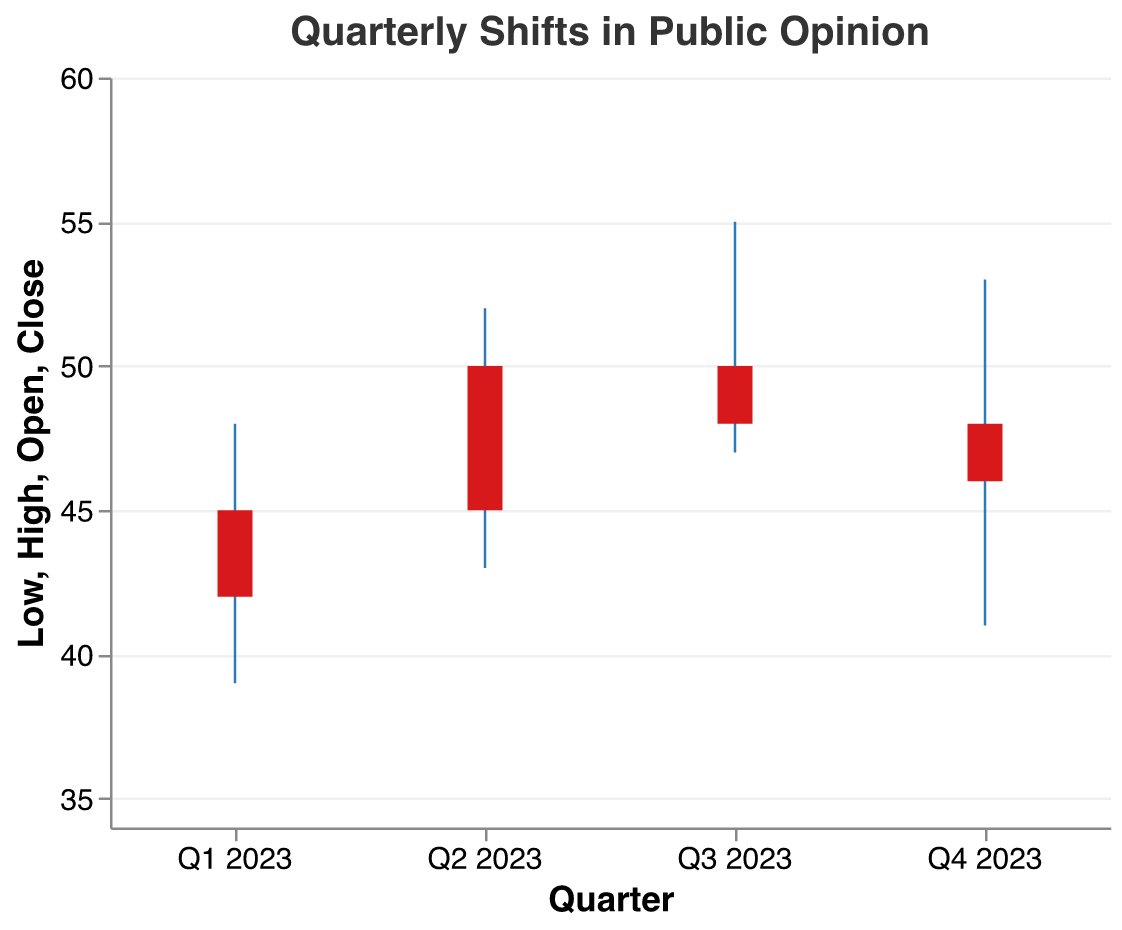What is the highest value of public opinion in Q3 2023? The highest value is represented by the "High" field for each quarter. For Q3 2023, the "High" value is 55
Answer: 55 What colors are used to represent the bar and the rule in the figure? The bar is colored red and the rule is colored blue
Answer: Red for bar, blue for rule What is the title of the figure? The title of the figure appears at the top and is: "Quarterly Shifts in Public Opinion"
Answer: Quarterly Shifts in Public Opinion Which quarter shows the largest increase in public opinion from open to close values? To find the quarter with the largest increase, subtract the "Open" value from the "Close" value for each quarter. Q1: 45-42=3, Q2: 50-45=5, Q3: 48-50=-2, Q4: 46-48=-2. The largest increase is in Q2 2023
Answer: Q2 2023 What are the open and close values for Q4 2023? Referencing the data points for Q4 2023, the open value is 48 and the close value is 46
Answer: Open: 48, Close: 46 Which quarter had the lowest minimum public opinion value, and what was it? The lowest minimum value corresponds to the "Low" field. Comparing all quarters, Q4 2023 had the lowest value of 41
Answer: Q4 2023, 41 How did the public opinion trend change from Q2 2023 to Q3 2023 considering the close values? The close value for Q2 2023 is 50 and for Q3 2023 is 48. A decrease (50 - 48) of 2 points occurred
Answer: Decreased by 2 points What is the average of the high values across all quarters in 2023? The high values are: 48 (Q1 2023), 52 (Q2 2023), 55 (Q3 2023), 53 (Q4 2023). Summing these values: 48 + 52 + 55 + 53 = 208. The average is 208/4 = 52
Answer: 52 Between which quarters did the public opinion display the greatest volatility based on high-low range? Volatility is measured by (High - Low). Calculate: Q1: 48-39=9, Q2: 52-43=9, Q3: 55-47=8, Q4: 53-41=12. The greatest volatility is in Q4 2023
Answer: Q4 2023 